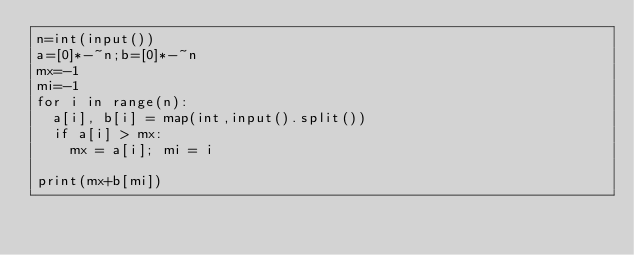<code> <loc_0><loc_0><loc_500><loc_500><_Python_>n=int(input())
a=[0]*-~n;b=[0]*-~n
mx=-1
mi=-1
for i in range(n):
  a[i], b[i] = map(int,input().split())
  if a[i] > mx:
    mx = a[i]; mi = i

print(mx+b[mi])</code> 